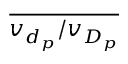<formula> <loc_0><loc_0><loc_500><loc_500>\overline { { v _ { d _ { p } } / v _ { D _ { p } } } }</formula> 